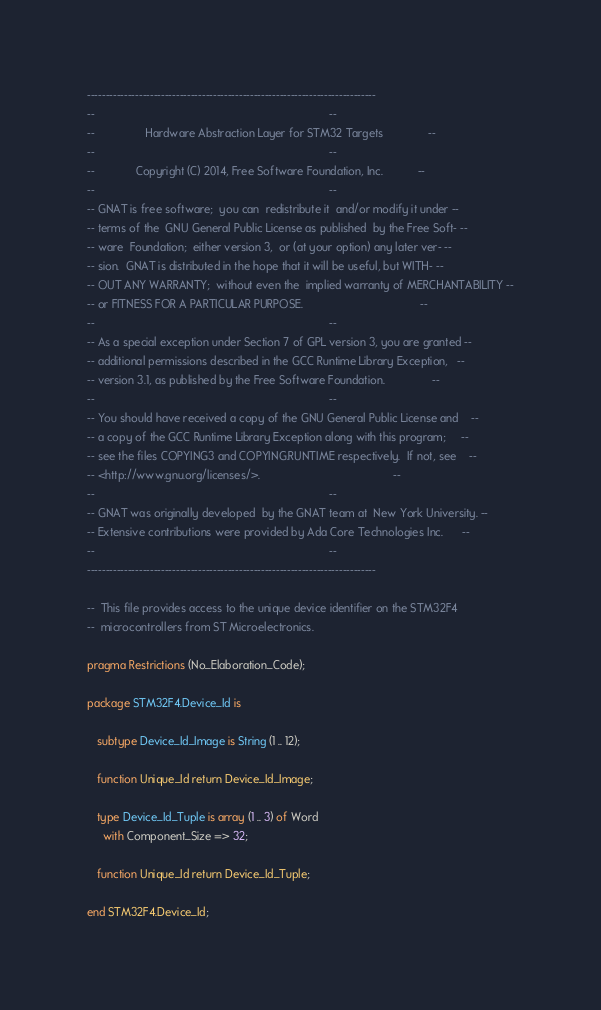<code> <loc_0><loc_0><loc_500><loc_500><_Ada_>------------------------------------------------------------------------------
--                                                                          --
--                Hardware Abstraction Layer for STM32 Targets              --
--                                                                          --
--             Copyright (C) 2014, Free Software Foundation, Inc.           --
--                                                                          --
-- GNAT is free software;  you can  redistribute it  and/or modify it under --
-- terms of the  GNU General Public License as published  by the Free Soft- --
-- ware  Foundation;  either version 3,  or (at your option) any later ver- --
-- sion.  GNAT is distributed in the hope that it will be useful, but WITH- --
-- OUT ANY WARRANTY;  without even the  implied warranty of MERCHANTABILITY --
-- or FITNESS FOR A PARTICULAR PURPOSE.                                     --
--                                                                          --
-- As a special exception under Section 7 of GPL version 3, you are granted --
-- additional permissions described in the GCC Runtime Library Exception,   --
-- version 3.1, as published by the Free Software Foundation.               --
--                                                                          --
-- You should have received a copy of the GNU General Public License and    --
-- a copy of the GCC Runtime Library Exception along with this program;     --
-- see the files COPYING3 and COPYING.RUNTIME respectively.  If not, see    --
-- <http://www.gnu.org/licenses/>.                                          --
--                                                                          --
-- GNAT was originally developed  by the GNAT team at  New York University. --
-- Extensive contributions were provided by Ada Core Technologies Inc.      --
--                                                                          --
------------------------------------------------------------------------------

--  This file provides access to the unique device identifier on the STM32F4
--  microcontrollers from ST Microelectronics.

pragma Restrictions (No_Elaboration_Code);

package STM32F4.Device_Id is

   subtype Device_Id_Image is String (1 .. 12);

   function Unique_Id return Device_Id_Image;

   type Device_Id_Tuple is array (1 .. 3) of Word
     with Component_Size => 32;

   function Unique_Id return Device_Id_Tuple;

end STM32F4.Device_Id;
</code> 